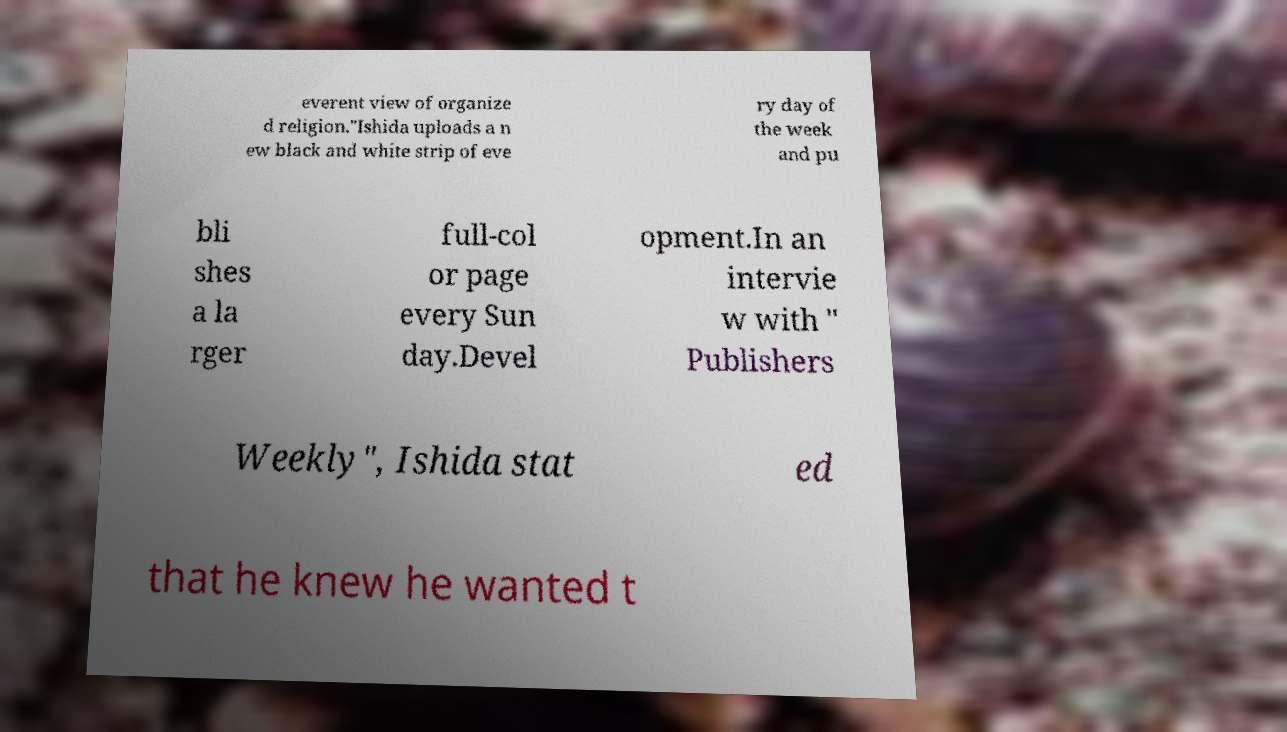Could you assist in decoding the text presented in this image and type it out clearly? everent view of organize d religion."Ishida uploads a n ew black and white strip of eve ry day of the week and pu bli shes a la rger full-col or page every Sun day.Devel opment.In an intervie w with " Publishers Weekly", Ishida stat ed that he knew he wanted t 